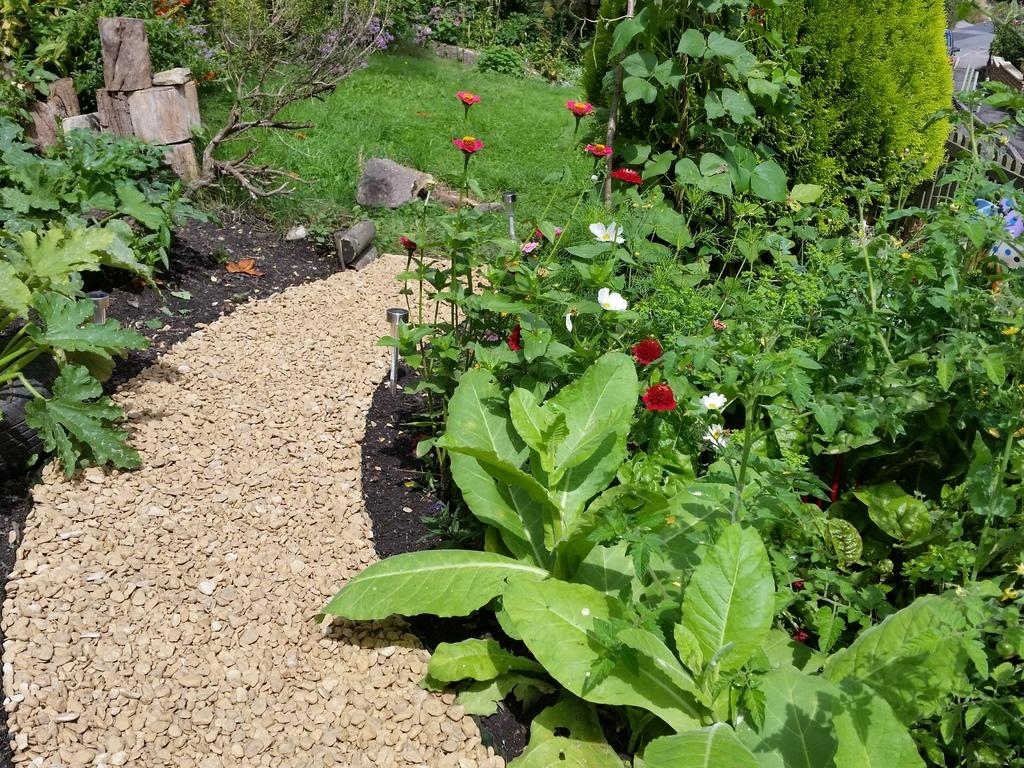What type of vegetation is present in the image? The image is filled with grass and plants. Can you describe the variety of flowers in the image? There are different flowers in the image. Where are the stones located in the image? The stones are in the bottom left corner of the image. What type of grass is the bat using to build its nest in the image? There is no bat or nest present in the image. 